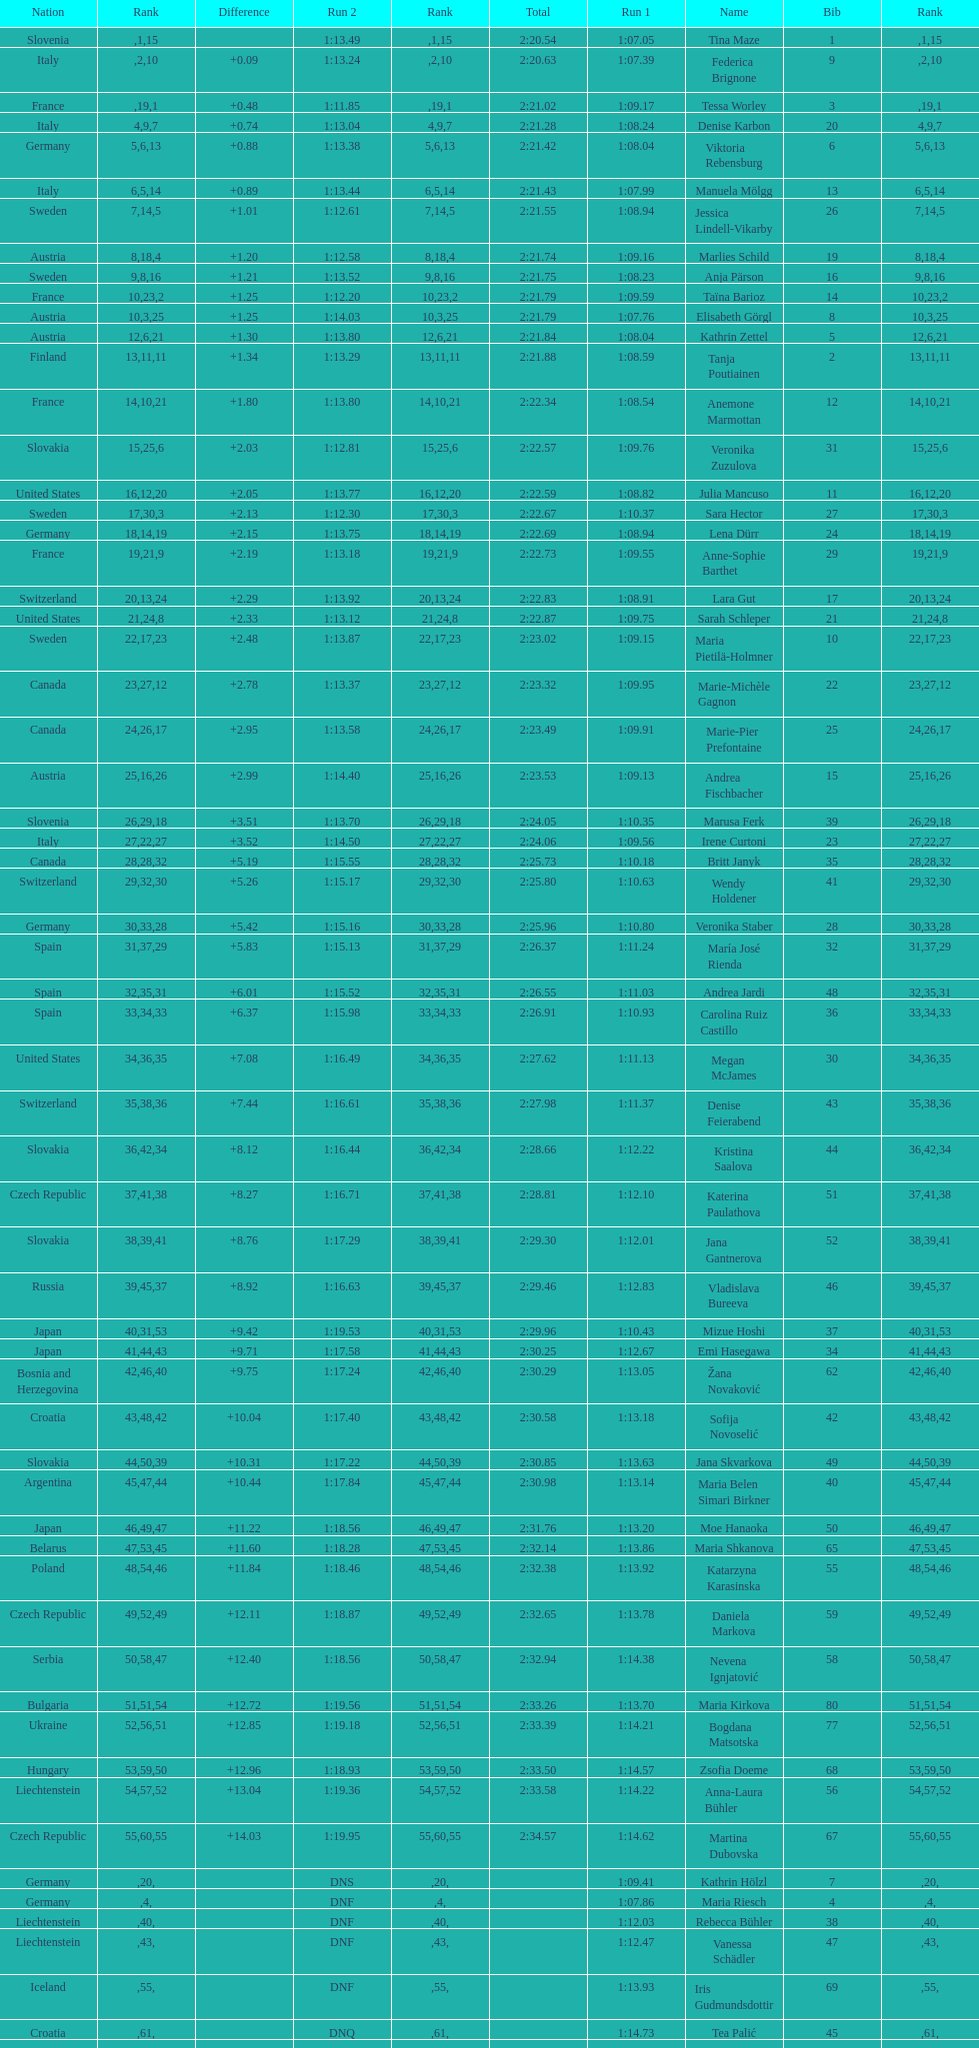How many total names are there? 116. 